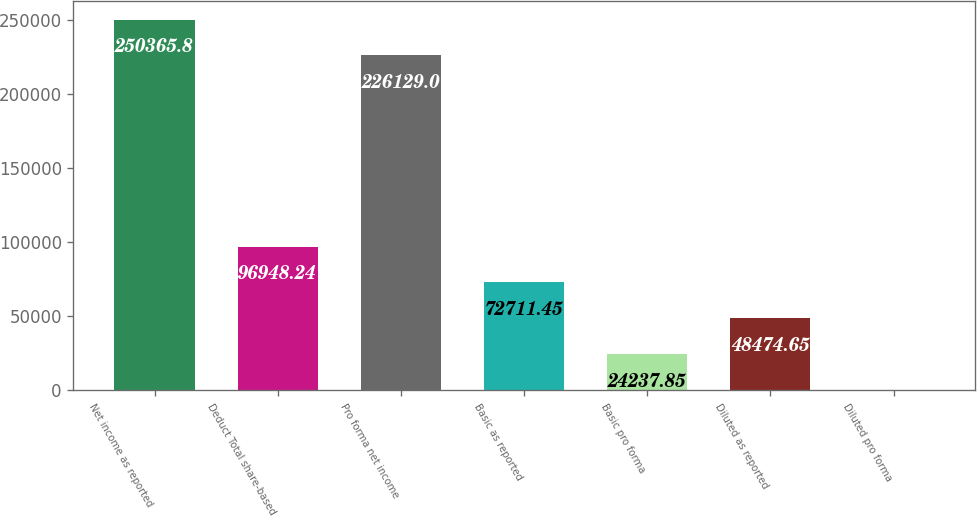Convert chart to OTSL. <chart><loc_0><loc_0><loc_500><loc_500><bar_chart><fcel>Net income as reported<fcel>Deduct Total share-based<fcel>Pro forma net income<fcel>Basic as reported<fcel>Basic pro forma<fcel>Diluted as reported<fcel>Diluted pro forma<nl><fcel>250366<fcel>96948.2<fcel>226129<fcel>72711.4<fcel>24237.8<fcel>48474.7<fcel>1.05<nl></chart> 